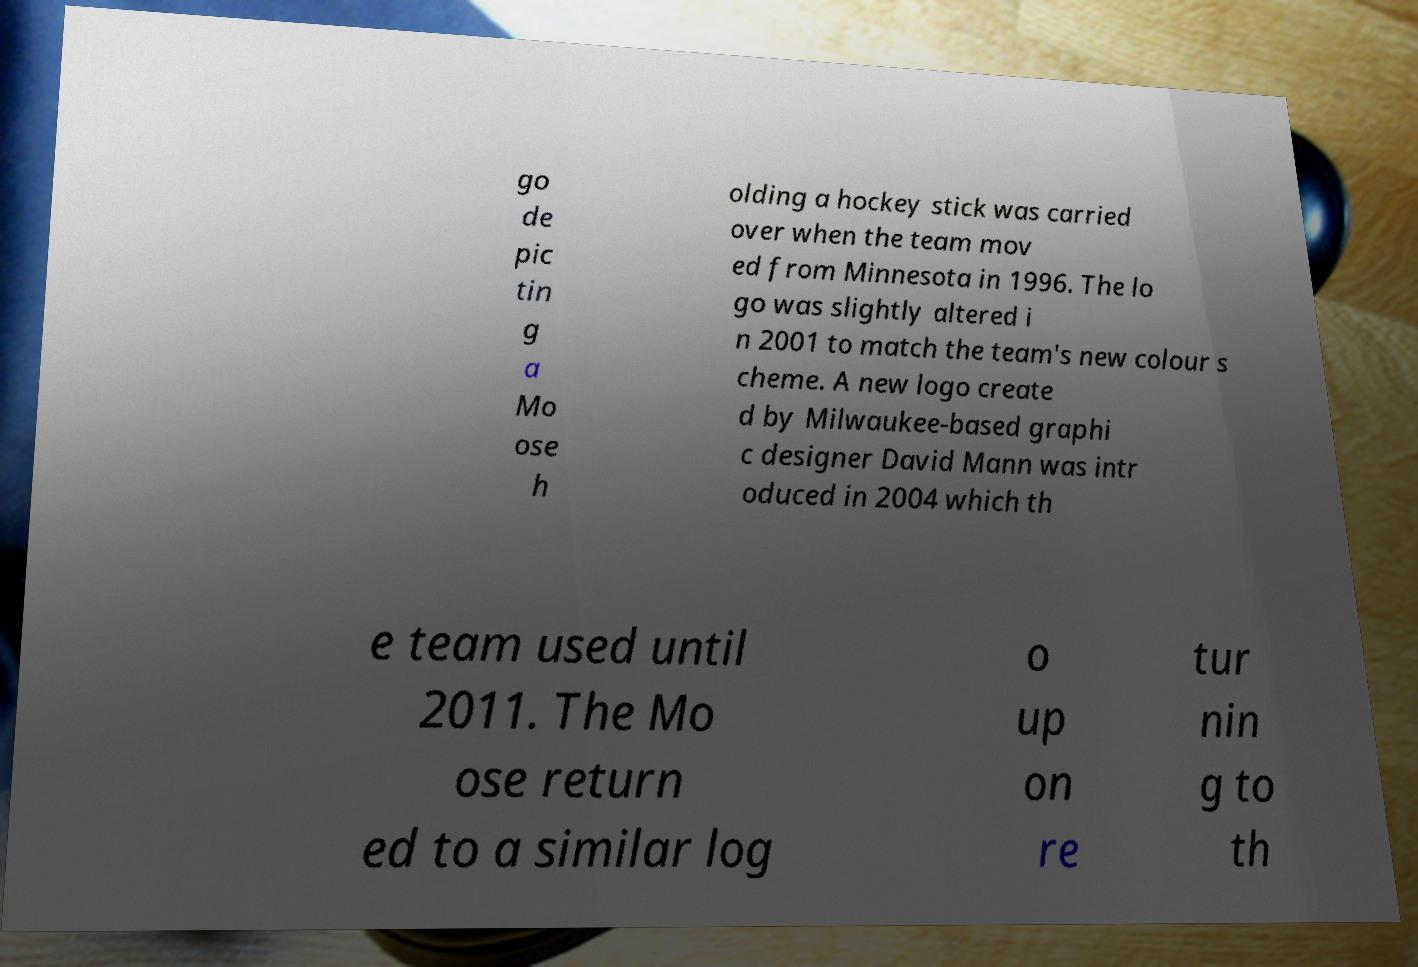Can you accurately transcribe the text from the provided image for me? go de pic tin g a Mo ose h olding a hockey stick was carried over when the team mov ed from Minnesota in 1996. The lo go was slightly altered i n 2001 to match the team's new colour s cheme. A new logo create d by Milwaukee-based graphi c designer David Mann was intr oduced in 2004 which th e team used until 2011. The Mo ose return ed to a similar log o up on re tur nin g to th 